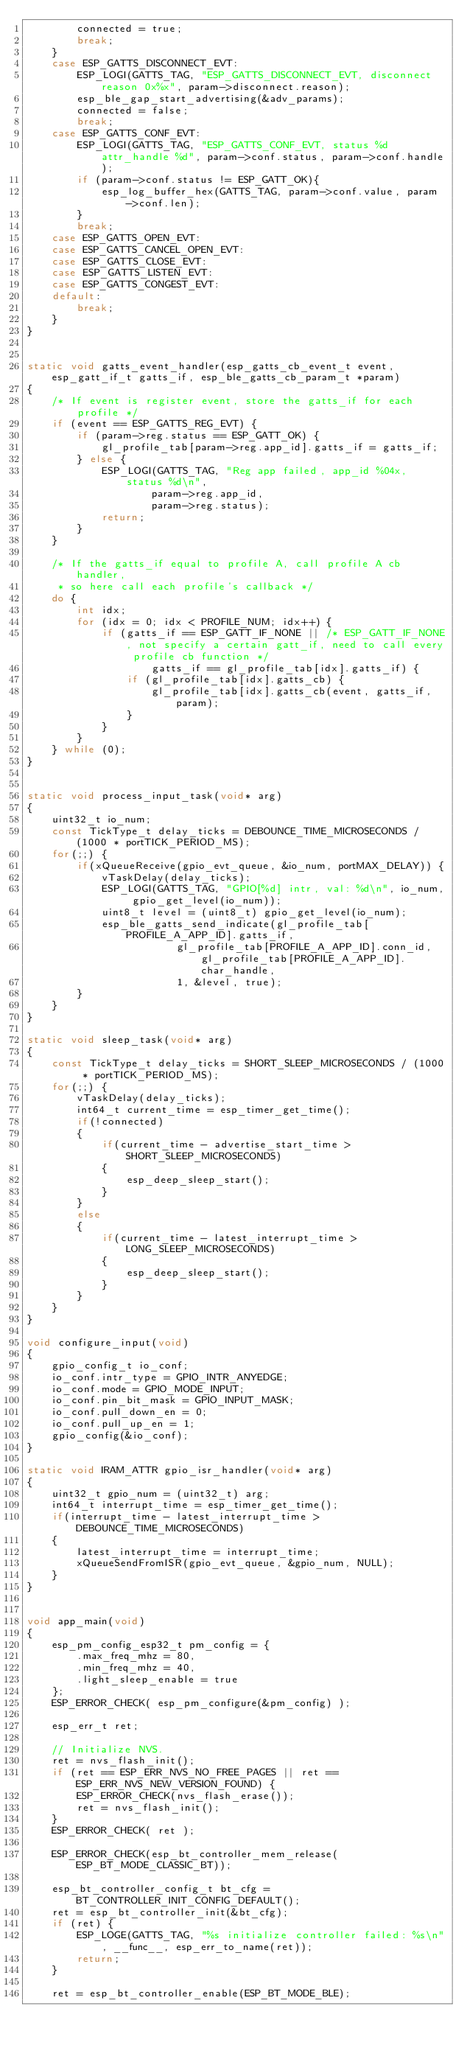<code> <loc_0><loc_0><loc_500><loc_500><_C_>        connected = true;
        break;
    }
    case ESP_GATTS_DISCONNECT_EVT:
        ESP_LOGI(GATTS_TAG, "ESP_GATTS_DISCONNECT_EVT, disconnect reason 0x%x", param->disconnect.reason);
        esp_ble_gap_start_advertising(&adv_params);
        connected = false;
        break;
    case ESP_GATTS_CONF_EVT:
        ESP_LOGI(GATTS_TAG, "ESP_GATTS_CONF_EVT, status %d attr_handle %d", param->conf.status, param->conf.handle);
        if (param->conf.status != ESP_GATT_OK){
            esp_log_buffer_hex(GATTS_TAG, param->conf.value, param->conf.len);
        }
        break;
    case ESP_GATTS_OPEN_EVT:
    case ESP_GATTS_CANCEL_OPEN_EVT:
    case ESP_GATTS_CLOSE_EVT:
    case ESP_GATTS_LISTEN_EVT:
    case ESP_GATTS_CONGEST_EVT:
    default:
        break;
    }
}


static void gatts_event_handler(esp_gatts_cb_event_t event, esp_gatt_if_t gatts_if, esp_ble_gatts_cb_param_t *param)
{
    /* If event is register event, store the gatts_if for each profile */
    if (event == ESP_GATTS_REG_EVT) {
        if (param->reg.status == ESP_GATT_OK) {
            gl_profile_tab[param->reg.app_id].gatts_if = gatts_if;
        } else {
            ESP_LOGI(GATTS_TAG, "Reg app failed, app_id %04x, status %d\n",
                    param->reg.app_id,
                    param->reg.status);
            return;
        }
    }

    /* If the gatts_if equal to profile A, call profile A cb handler,
     * so here call each profile's callback */
    do {
        int idx;
        for (idx = 0; idx < PROFILE_NUM; idx++) {
            if (gatts_if == ESP_GATT_IF_NONE || /* ESP_GATT_IF_NONE, not specify a certain gatt_if, need to call every profile cb function */
                    gatts_if == gl_profile_tab[idx].gatts_if) {
                if (gl_profile_tab[idx].gatts_cb) {
                    gl_profile_tab[idx].gatts_cb(event, gatts_if, param);
                }
            }
        }
    } while (0);
}


static void process_input_task(void* arg)
{
    uint32_t io_num;
    const TickType_t delay_ticks = DEBOUNCE_TIME_MICROSECONDS / (1000 * portTICK_PERIOD_MS);
    for(;;) {
        if(xQueueReceive(gpio_evt_queue, &io_num, portMAX_DELAY)) {
            vTaskDelay(delay_ticks);
            ESP_LOGI(GATTS_TAG, "GPIO[%d] intr, val: %d\n", io_num, gpio_get_level(io_num));
            uint8_t level = (uint8_t) gpio_get_level(io_num);
            esp_ble_gatts_send_indicate(gl_profile_tab[PROFILE_A_APP_ID].gatts_if,
                        gl_profile_tab[PROFILE_A_APP_ID].conn_id, gl_profile_tab[PROFILE_A_APP_ID].char_handle, 
                        1, &level, true);
        }
    }
}

static void sleep_task(void* arg)
{
    const TickType_t delay_ticks = SHORT_SLEEP_MICROSECONDS / (1000 * portTICK_PERIOD_MS);
    for(;;) {
        vTaskDelay(delay_ticks);
        int64_t current_time = esp_timer_get_time();
        if(!connected)
        {
            if(current_time - advertise_start_time > SHORT_SLEEP_MICROSECONDS)
            {
                esp_deep_sleep_start();
            }
        }
        else
        {
            if(current_time - latest_interrupt_time > LONG_SLEEP_MICROSECONDS)
            {
                esp_deep_sleep_start();
            }
        }
    }
}

void configure_input(void)
{
    gpio_config_t io_conf;
    io_conf.intr_type = GPIO_INTR_ANYEDGE;
    io_conf.mode = GPIO_MODE_INPUT;
    io_conf.pin_bit_mask = GPIO_INPUT_MASK;
    io_conf.pull_down_en = 0;
    io_conf.pull_up_en = 1;
    gpio_config(&io_conf);
}

static void IRAM_ATTR gpio_isr_handler(void* arg)
{
    uint32_t gpio_num = (uint32_t) arg;
    int64_t interrupt_time = esp_timer_get_time();
    if(interrupt_time - latest_interrupt_time > DEBOUNCE_TIME_MICROSECONDS)
    {
        latest_interrupt_time = interrupt_time;
        xQueueSendFromISR(gpio_evt_queue, &gpio_num, NULL);
    }
}


void app_main(void)
{
    esp_pm_config_esp32_t pm_config = {
        .max_freq_mhz = 80,
        .min_freq_mhz = 40,
        .light_sleep_enable = true
    };
    ESP_ERROR_CHECK( esp_pm_configure(&pm_config) );

    esp_err_t ret;

    // Initialize NVS.
    ret = nvs_flash_init();
    if (ret == ESP_ERR_NVS_NO_FREE_PAGES || ret == ESP_ERR_NVS_NEW_VERSION_FOUND) {
        ESP_ERROR_CHECK(nvs_flash_erase());
        ret = nvs_flash_init();
    }
    ESP_ERROR_CHECK( ret );

    ESP_ERROR_CHECK(esp_bt_controller_mem_release(ESP_BT_MODE_CLASSIC_BT));

    esp_bt_controller_config_t bt_cfg = BT_CONTROLLER_INIT_CONFIG_DEFAULT();
    ret = esp_bt_controller_init(&bt_cfg);
    if (ret) {
        ESP_LOGE(GATTS_TAG, "%s initialize controller failed: %s\n", __func__, esp_err_to_name(ret));
        return;
    }

    ret = esp_bt_controller_enable(ESP_BT_MODE_BLE);</code> 